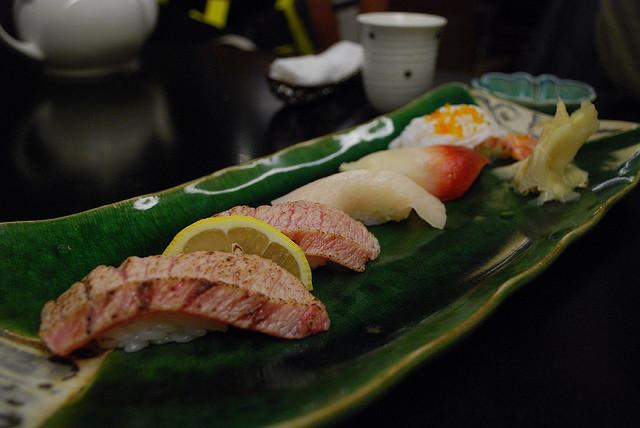Why would someone sit at this table? to eat 